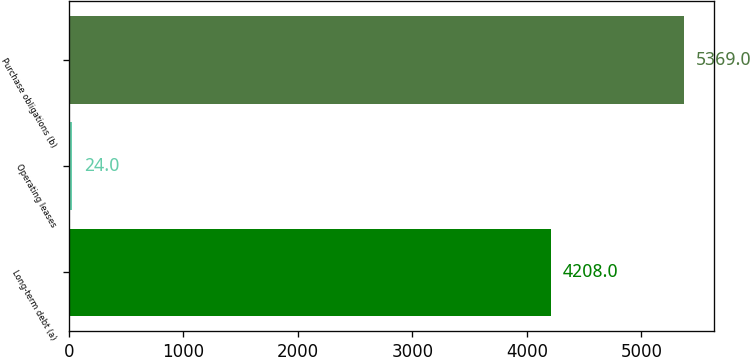Convert chart to OTSL. <chart><loc_0><loc_0><loc_500><loc_500><bar_chart><fcel>Long-term debt (a)<fcel>Operating leases<fcel>Purchase obligations (b)<nl><fcel>4208<fcel>24<fcel>5369<nl></chart> 